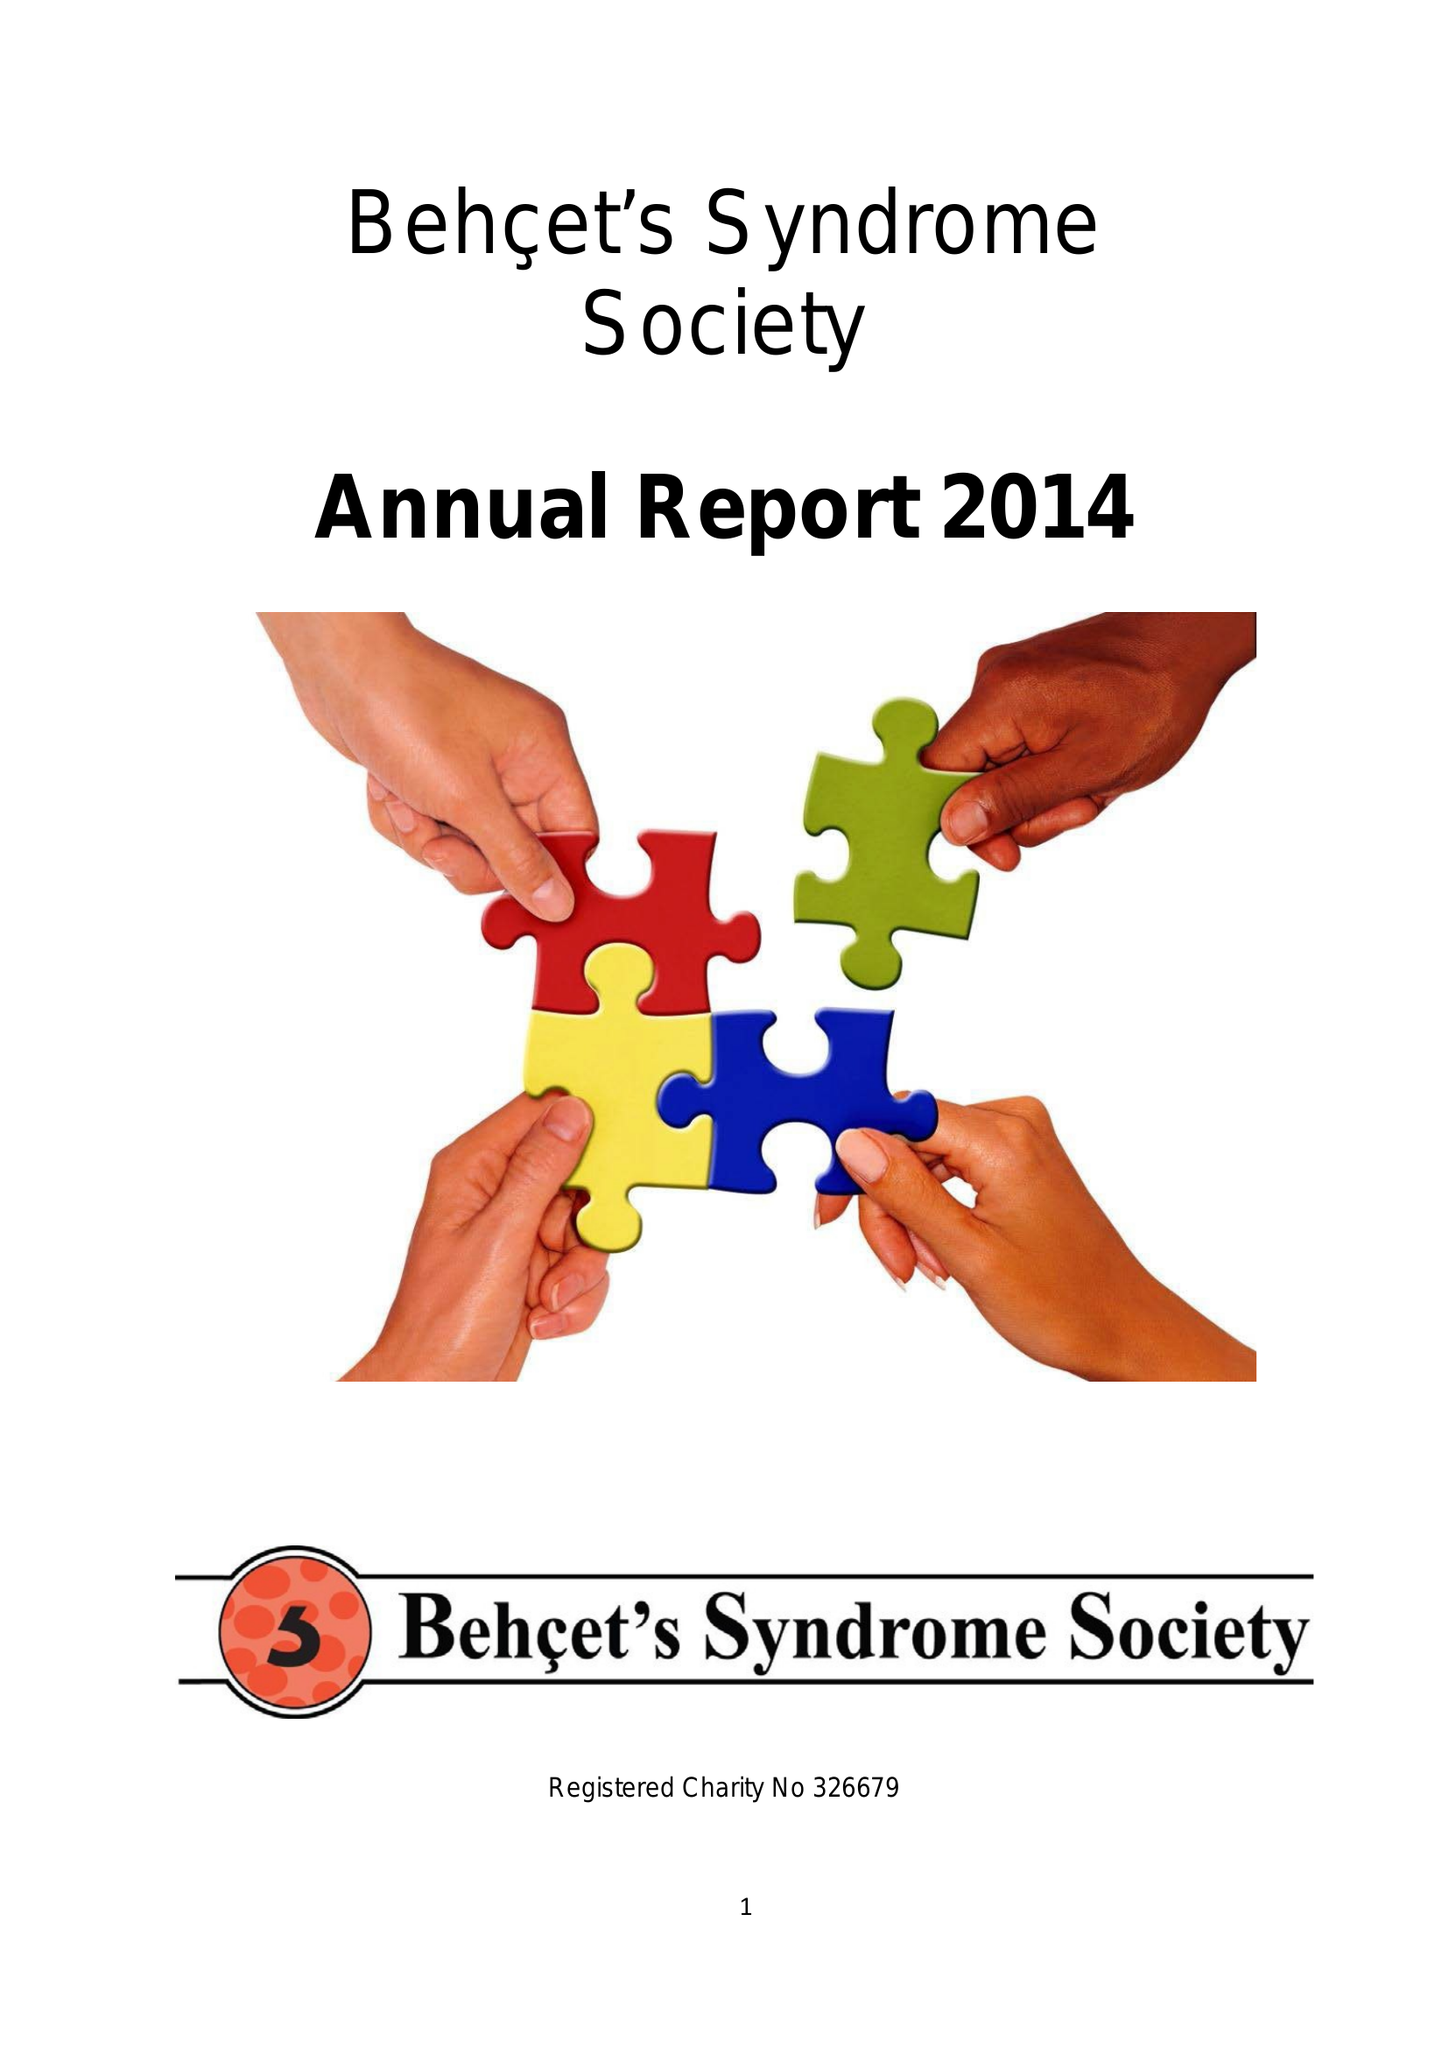What is the value for the address__street_line?
Answer the question using a single word or phrase. 152-160 CITY ROAD 